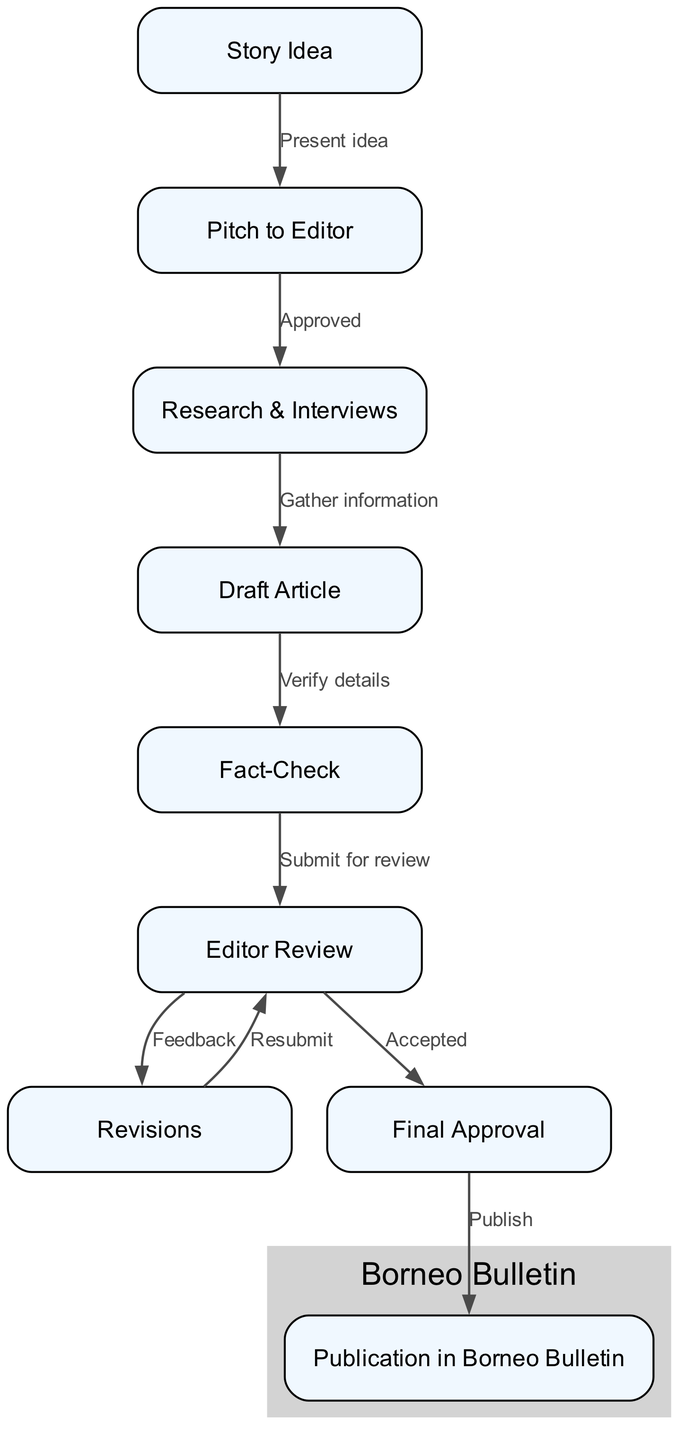What is the first step in the news reporting process? The flow chart starts with "Story Idea" as the first node, showing it as the initial step in the process.
Answer: Story Idea How many nodes are there in the diagram? By counting the distinct nodes listed, there are a total of 9 nodes representing different steps in the process.
Answer: 9 What action follows "Pitch to Editor"? The chart shows that "Research & Interviews" follows "Pitch to Editor", indicating the next step after the pitch is approved.
Answer: Research & Interviews Which step follows "Fact-Check"? According to the diagram, the step following "Fact-Check" is "Editor Review", showing the progression towards getting the article reviewed.
Answer: Editor Review What is the final step before publication? The flow chart indicates "Final Approval" is the last step before the article is published, making it a critical stage in the process.
Answer: Final Approval What connects "Research & Interviews" to "Draft Article"? The chart highlights that "Gather information" is the connecting action between "Research & Interviews" and "Draft Article", showing the relationship between these two steps.
Answer: Gather information What happens if the article is not accepted after "Editor Review"? If the article is not accepted after "Editor Review", it goes back to "Revisions", as indicated in the edge connecting these nodes, signifying the iterative nature of the process.
Answer: Revisions How does "Revisions" relate to "Editor Review"? The flow chart shows a feedback loop where "Revisions" leads back to "Editor Review" for additional evaluation after making edits based on editor feedback.
Answer: Resubmit How many edges connect the nodes in the chart? By counting the connections between the nodes, the diagram displays 8 edges, representing the various relationships and transitions between the steps.
Answer: 8 